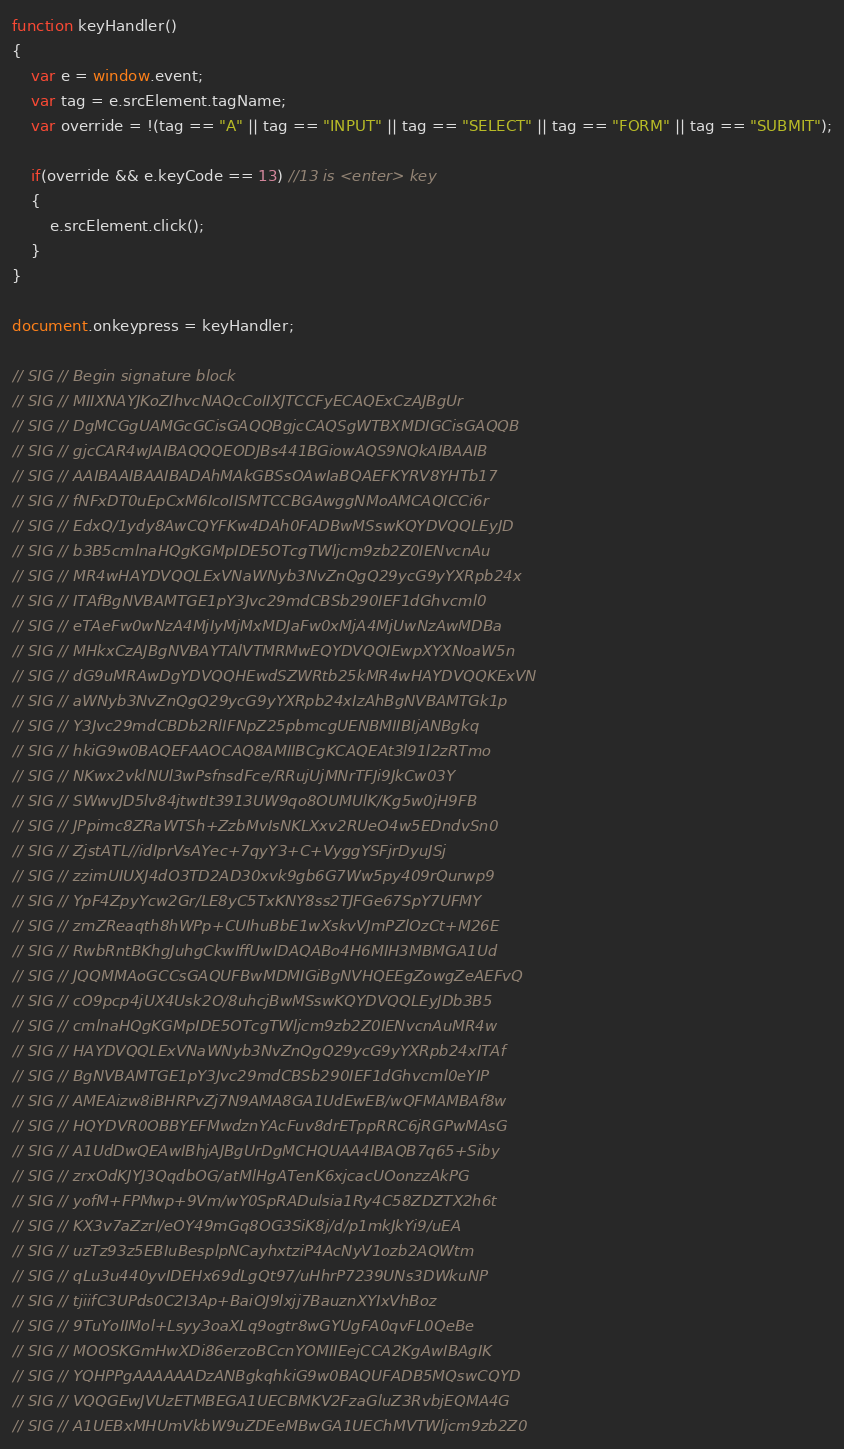<code> <loc_0><loc_0><loc_500><loc_500><_JavaScript_>
function keyHandler()
{
	var e = window.event;
	var tag = e.srcElement.tagName;
	var override = !(tag == "A" || tag == "INPUT" || tag == "SELECT" || tag == "FORM" || tag == "SUBMIT");
	
	if(override && e.keyCode == 13) //13 is <enter> key
	{
		e.srcElement.click();
	}
}

document.onkeypress = keyHandler;

// SIG // Begin signature block
// SIG // MIIXNAYJKoZIhvcNAQcCoIIXJTCCFyECAQExCzAJBgUr
// SIG // DgMCGgUAMGcGCisGAQQBgjcCAQSgWTBXMDIGCisGAQQB
// SIG // gjcCAR4wJAIBAQQQEODJBs441BGiowAQS9NQkAIBAAIB
// SIG // AAIBAAIBAAIBADAhMAkGBSsOAwIaBQAEFKYRV8YHTb17
// SIG // fNFxDT0uEpCxM6IcoIISMTCCBGAwggNMoAMCAQICCi6r
// SIG // EdxQ/1ydy8AwCQYFKw4DAh0FADBwMSswKQYDVQQLEyJD
// SIG // b3B5cmlnaHQgKGMpIDE5OTcgTWljcm9zb2Z0IENvcnAu
// SIG // MR4wHAYDVQQLExVNaWNyb3NvZnQgQ29ycG9yYXRpb24x
// SIG // ITAfBgNVBAMTGE1pY3Jvc29mdCBSb290IEF1dGhvcml0
// SIG // eTAeFw0wNzA4MjIyMjMxMDJaFw0xMjA4MjUwNzAwMDBa
// SIG // MHkxCzAJBgNVBAYTAlVTMRMwEQYDVQQIEwpXYXNoaW5n
// SIG // dG9uMRAwDgYDVQQHEwdSZWRtb25kMR4wHAYDVQQKExVN
// SIG // aWNyb3NvZnQgQ29ycG9yYXRpb24xIzAhBgNVBAMTGk1p
// SIG // Y3Jvc29mdCBDb2RlIFNpZ25pbmcgUENBMIIBIjANBgkq
// SIG // hkiG9w0BAQEFAAOCAQ8AMIIBCgKCAQEAt3l91l2zRTmo
// SIG // NKwx2vklNUl3wPsfnsdFce/RRujUjMNrTFJi9JkCw03Y
// SIG // SWwvJD5lv84jtwtIt3913UW9qo8OUMUlK/Kg5w0jH9FB
// SIG // JPpimc8ZRaWTSh+ZzbMvIsNKLXxv2RUeO4w5EDndvSn0
// SIG // ZjstATL//idIprVsAYec+7qyY3+C+VyggYSFjrDyuJSj
// SIG // zzimUIUXJ4dO3TD2AD30xvk9gb6G7Ww5py409rQurwp9
// SIG // YpF4ZpyYcw2Gr/LE8yC5TxKNY8ss2TJFGe67SpY7UFMY
// SIG // zmZReaqth8hWPp+CUIhuBbE1wXskvVJmPZlOzCt+M26E
// SIG // RwbRntBKhgJuhgCkwIffUwIDAQABo4H6MIH3MBMGA1Ud
// SIG // JQQMMAoGCCsGAQUFBwMDMIGiBgNVHQEEgZowgZeAEFvQ
// SIG // cO9pcp4jUX4Usk2O/8uhcjBwMSswKQYDVQQLEyJDb3B5
// SIG // cmlnaHQgKGMpIDE5OTcgTWljcm9zb2Z0IENvcnAuMR4w
// SIG // HAYDVQQLExVNaWNyb3NvZnQgQ29ycG9yYXRpb24xITAf
// SIG // BgNVBAMTGE1pY3Jvc29mdCBSb290IEF1dGhvcml0eYIP
// SIG // AMEAizw8iBHRPvZj7N9AMA8GA1UdEwEB/wQFMAMBAf8w
// SIG // HQYDVR0OBBYEFMwdznYAcFuv8drETppRRC6jRGPwMAsG
// SIG // A1UdDwQEAwIBhjAJBgUrDgMCHQUAA4IBAQB7q65+Siby
// SIG // zrxOdKJYJ3QqdbOG/atMlHgATenK6xjcacUOonzzAkPG
// SIG // yofM+FPMwp+9Vm/wY0SpRADulsia1Ry4C58ZDZTX2h6t
// SIG // KX3v7aZzrI/eOY49mGq8OG3SiK8j/d/p1mkJkYi9/uEA
// SIG // uzTz93z5EBIuBesplpNCayhxtziP4AcNyV1ozb2AQWtm
// SIG // qLu3u440yvIDEHx69dLgQt97/uHhrP7239UNs3DWkuNP
// SIG // tjiifC3UPds0C2I3Ap+BaiOJ9lxjj7BauznXYIxVhBoz
// SIG // 9TuYoIIMol+Lsyy3oaXLq9ogtr8wGYUgFA0qvFL0QeBe
// SIG // MOOSKGmHwXDi86erzoBCcnYOMIIEejCCA2KgAwIBAgIK
// SIG // YQHPPgAAAAAADzANBgkqhkiG9w0BAQUFADB5MQswCQYD
// SIG // VQQGEwJVUzETMBEGA1UECBMKV2FzaGluZ3RvbjEQMA4G
// SIG // A1UEBxMHUmVkbW9uZDEeMBwGA1UEChMVTWljcm9zb2Z0</code> 